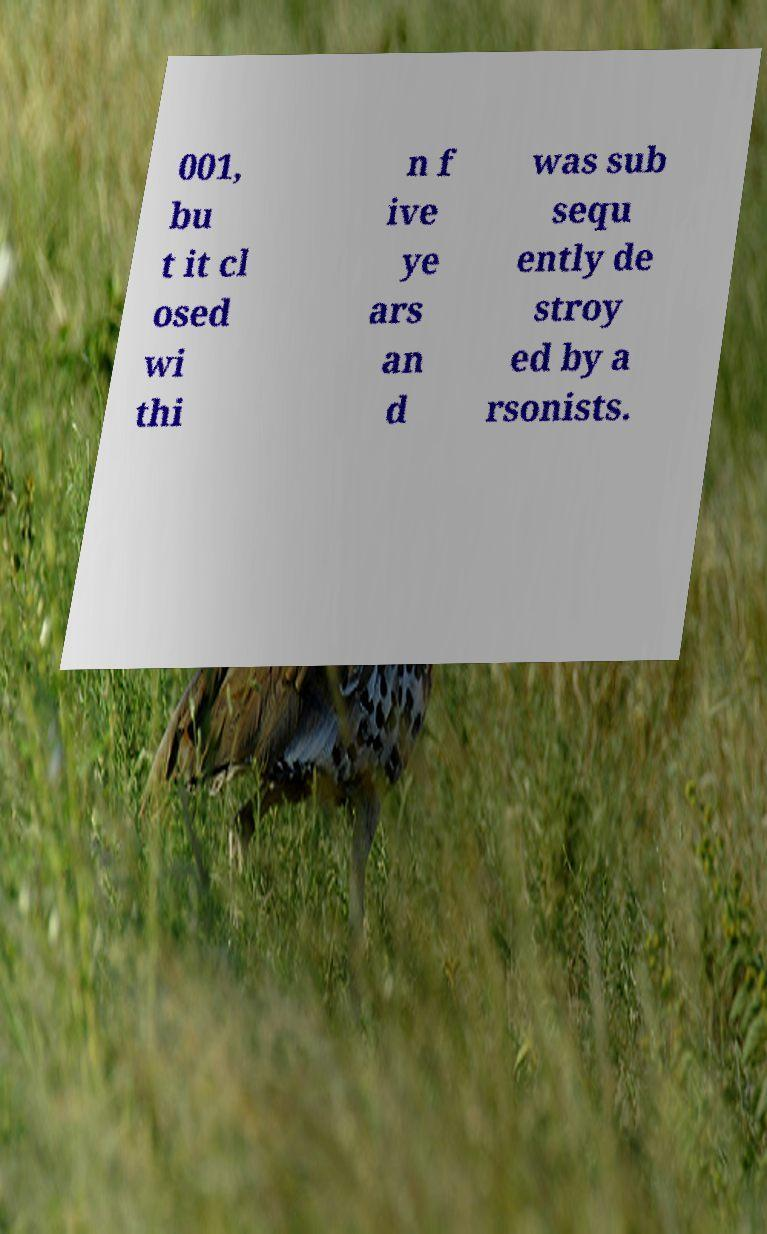Can you accurately transcribe the text from the provided image for me? 001, bu t it cl osed wi thi n f ive ye ars an d was sub sequ ently de stroy ed by a rsonists. 